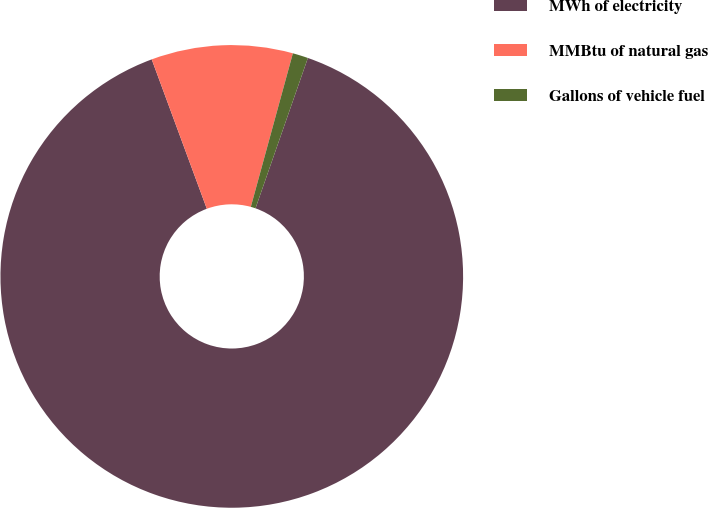<chart> <loc_0><loc_0><loc_500><loc_500><pie_chart><fcel>MWh of electricity<fcel>MMBtu of natural gas<fcel>Gallons of vehicle fuel<nl><fcel>89.04%<fcel>9.88%<fcel>1.08%<nl></chart> 